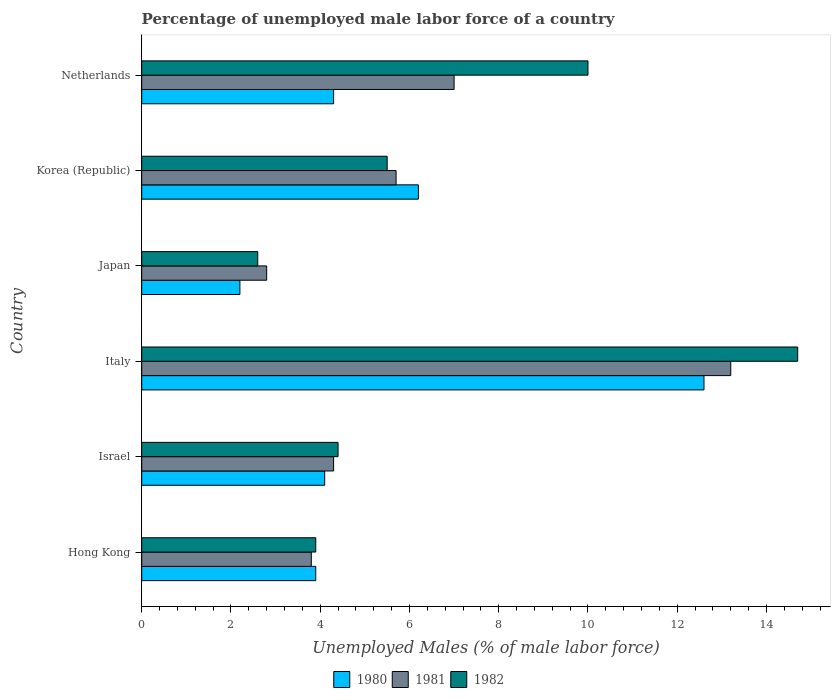How many different coloured bars are there?
Ensure brevity in your answer.  3. How many groups of bars are there?
Give a very brief answer. 6. Are the number of bars on each tick of the Y-axis equal?
Keep it short and to the point. Yes. How many bars are there on the 5th tick from the top?
Your response must be concise. 3. In how many cases, is the number of bars for a given country not equal to the number of legend labels?
Your response must be concise. 0. What is the percentage of unemployed male labor force in 1982 in Korea (Republic)?
Make the answer very short. 5.5. Across all countries, what is the maximum percentage of unemployed male labor force in 1982?
Your answer should be compact. 14.7. Across all countries, what is the minimum percentage of unemployed male labor force in 1982?
Provide a succinct answer. 2.6. What is the total percentage of unemployed male labor force in 1980 in the graph?
Ensure brevity in your answer.  33.3. What is the difference between the percentage of unemployed male labor force in 1982 in Hong Kong and that in Japan?
Ensure brevity in your answer.  1.3. What is the difference between the percentage of unemployed male labor force in 1980 in Japan and the percentage of unemployed male labor force in 1981 in Hong Kong?
Your answer should be very brief. -1.6. What is the average percentage of unemployed male labor force in 1982 per country?
Provide a succinct answer. 6.85. What is the difference between the percentage of unemployed male labor force in 1980 and percentage of unemployed male labor force in 1981 in Hong Kong?
Offer a terse response. 0.1. In how many countries, is the percentage of unemployed male labor force in 1980 greater than 5.6 %?
Your answer should be compact. 2. What is the ratio of the percentage of unemployed male labor force in 1981 in Hong Kong to that in Italy?
Provide a succinct answer. 0.29. Is the difference between the percentage of unemployed male labor force in 1980 in Italy and Netherlands greater than the difference between the percentage of unemployed male labor force in 1981 in Italy and Netherlands?
Your answer should be compact. Yes. What is the difference between the highest and the second highest percentage of unemployed male labor force in 1981?
Offer a terse response. 6.2. What is the difference between the highest and the lowest percentage of unemployed male labor force in 1980?
Keep it short and to the point. 10.4. What does the 1st bar from the top in Korea (Republic) represents?
Provide a short and direct response. 1982. What does the 3rd bar from the bottom in Israel represents?
Offer a terse response. 1982. Are all the bars in the graph horizontal?
Provide a short and direct response. Yes. How many countries are there in the graph?
Provide a succinct answer. 6. What is the difference between two consecutive major ticks on the X-axis?
Keep it short and to the point. 2. Does the graph contain any zero values?
Make the answer very short. No. Does the graph contain grids?
Offer a terse response. No. What is the title of the graph?
Give a very brief answer. Percentage of unemployed male labor force of a country. What is the label or title of the X-axis?
Offer a terse response. Unemployed Males (% of male labor force). What is the label or title of the Y-axis?
Your response must be concise. Country. What is the Unemployed Males (% of male labor force) in 1980 in Hong Kong?
Your response must be concise. 3.9. What is the Unemployed Males (% of male labor force) of 1981 in Hong Kong?
Offer a very short reply. 3.8. What is the Unemployed Males (% of male labor force) in 1982 in Hong Kong?
Provide a succinct answer. 3.9. What is the Unemployed Males (% of male labor force) of 1980 in Israel?
Offer a very short reply. 4.1. What is the Unemployed Males (% of male labor force) of 1981 in Israel?
Your answer should be compact. 4.3. What is the Unemployed Males (% of male labor force) in 1982 in Israel?
Keep it short and to the point. 4.4. What is the Unemployed Males (% of male labor force) in 1980 in Italy?
Provide a succinct answer. 12.6. What is the Unemployed Males (% of male labor force) of 1981 in Italy?
Offer a very short reply. 13.2. What is the Unemployed Males (% of male labor force) of 1982 in Italy?
Make the answer very short. 14.7. What is the Unemployed Males (% of male labor force) of 1980 in Japan?
Your answer should be very brief. 2.2. What is the Unemployed Males (% of male labor force) in 1981 in Japan?
Provide a short and direct response. 2.8. What is the Unemployed Males (% of male labor force) of 1982 in Japan?
Your answer should be very brief. 2.6. What is the Unemployed Males (% of male labor force) of 1980 in Korea (Republic)?
Your answer should be very brief. 6.2. What is the Unemployed Males (% of male labor force) in 1981 in Korea (Republic)?
Give a very brief answer. 5.7. What is the Unemployed Males (% of male labor force) of 1980 in Netherlands?
Offer a terse response. 4.3. What is the Unemployed Males (% of male labor force) of 1982 in Netherlands?
Offer a terse response. 10. Across all countries, what is the maximum Unemployed Males (% of male labor force) of 1980?
Ensure brevity in your answer.  12.6. Across all countries, what is the maximum Unemployed Males (% of male labor force) in 1981?
Your response must be concise. 13.2. Across all countries, what is the maximum Unemployed Males (% of male labor force) in 1982?
Provide a succinct answer. 14.7. Across all countries, what is the minimum Unemployed Males (% of male labor force) in 1980?
Provide a short and direct response. 2.2. Across all countries, what is the minimum Unemployed Males (% of male labor force) of 1981?
Offer a terse response. 2.8. Across all countries, what is the minimum Unemployed Males (% of male labor force) of 1982?
Ensure brevity in your answer.  2.6. What is the total Unemployed Males (% of male labor force) of 1980 in the graph?
Make the answer very short. 33.3. What is the total Unemployed Males (% of male labor force) in 1981 in the graph?
Make the answer very short. 36.8. What is the total Unemployed Males (% of male labor force) of 1982 in the graph?
Your answer should be compact. 41.1. What is the difference between the Unemployed Males (% of male labor force) in 1980 in Hong Kong and that in Israel?
Ensure brevity in your answer.  -0.2. What is the difference between the Unemployed Males (% of male labor force) in 1981 in Hong Kong and that in Italy?
Make the answer very short. -9.4. What is the difference between the Unemployed Males (% of male labor force) in 1980 in Hong Kong and that in Japan?
Offer a very short reply. 1.7. What is the difference between the Unemployed Males (% of male labor force) in 1981 in Hong Kong and that in Japan?
Provide a short and direct response. 1. What is the difference between the Unemployed Males (% of male labor force) in 1982 in Hong Kong and that in Japan?
Ensure brevity in your answer.  1.3. What is the difference between the Unemployed Males (% of male labor force) of 1980 in Hong Kong and that in Korea (Republic)?
Your answer should be very brief. -2.3. What is the difference between the Unemployed Males (% of male labor force) in 1981 in Hong Kong and that in Korea (Republic)?
Offer a very short reply. -1.9. What is the difference between the Unemployed Males (% of male labor force) in 1982 in Hong Kong and that in Korea (Republic)?
Keep it short and to the point. -1.6. What is the difference between the Unemployed Males (% of male labor force) of 1980 in Hong Kong and that in Netherlands?
Make the answer very short. -0.4. What is the difference between the Unemployed Males (% of male labor force) in 1982 in Hong Kong and that in Netherlands?
Keep it short and to the point. -6.1. What is the difference between the Unemployed Males (% of male labor force) of 1980 in Israel and that in Italy?
Your answer should be very brief. -8.5. What is the difference between the Unemployed Males (% of male labor force) of 1981 in Israel and that in Italy?
Provide a short and direct response. -8.9. What is the difference between the Unemployed Males (% of male labor force) of 1982 in Israel and that in Italy?
Your response must be concise. -10.3. What is the difference between the Unemployed Males (% of male labor force) in 1981 in Israel and that in Japan?
Give a very brief answer. 1.5. What is the difference between the Unemployed Males (% of male labor force) in 1981 in Israel and that in Korea (Republic)?
Provide a succinct answer. -1.4. What is the difference between the Unemployed Males (% of male labor force) in 1980 in Israel and that in Netherlands?
Make the answer very short. -0.2. What is the difference between the Unemployed Males (% of male labor force) in 1981 in Italy and that in Japan?
Give a very brief answer. 10.4. What is the difference between the Unemployed Males (% of male labor force) of 1980 in Italy and that in Korea (Republic)?
Provide a short and direct response. 6.4. What is the difference between the Unemployed Males (% of male labor force) in 1981 in Italy and that in Netherlands?
Offer a very short reply. 6.2. What is the difference between the Unemployed Males (% of male labor force) in 1980 in Japan and that in Korea (Republic)?
Provide a succinct answer. -4. What is the difference between the Unemployed Males (% of male labor force) of 1982 in Japan and that in Korea (Republic)?
Make the answer very short. -2.9. What is the difference between the Unemployed Males (% of male labor force) in 1982 in Japan and that in Netherlands?
Make the answer very short. -7.4. What is the difference between the Unemployed Males (% of male labor force) of 1981 in Korea (Republic) and that in Netherlands?
Offer a very short reply. -1.3. What is the difference between the Unemployed Males (% of male labor force) in 1980 in Hong Kong and the Unemployed Males (% of male labor force) in 1981 in Israel?
Your answer should be compact. -0.4. What is the difference between the Unemployed Males (% of male labor force) of 1980 in Hong Kong and the Unemployed Males (% of male labor force) of 1981 in Italy?
Your answer should be compact. -9.3. What is the difference between the Unemployed Males (% of male labor force) in 1980 in Hong Kong and the Unemployed Males (% of male labor force) in 1982 in Italy?
Your answer should be very brief. -10.8. What is the difference between the Unemployed Males (% of male labor force) of 1980 in Hong Kong and the Unemployed Males (% of male labor force) of 1981 in Japan?
Provide a succinct answer. 1.1. What is the difference between the Unemployed Males (% of male labor force) in 1980 in Hong Kong and the Unemployed Males (% of male labor force) in 1982 in Japan?
Your response must be concise. 1.3. What is the difference between the Unemployed Males (% of male labor force) in 1981 in Hong Kong and the Unemployed Males (% of male labor force) in 1982 in Japan?
Offer a very short reply. 1.2. What is the difference between the Unemployed Males (% of male labor force) of 1980 in Hong Kong and the Unemployed Males (% of male labor force) of 1981 in Korea (Republic)?
Your answer should be compact. -1.8. What is the difference between the Unemployed Males (% of male labor force) of 1981 in Hong Kong and the Unemployed Males (% of male labor force) of 1982 in Korea (Republic)?
Offer a very short reply. -1.7. What is the difference between the Unemployed Males (% of male labor force) of 1980 in Hong Kong and the Unemployed Males (% of male labor force) of 1981 in Netherlands?
Keep it short and to the point. -3.1. What is the difference between the Unemployed Males (% of male labor force) of 1980 in Israel and the Unemployed Males (% of male labor force) of 1981 in Italy?
Your response must be concise. -9.1. What is the difference between the Unemployed Males (% of male labor force) in 1980 in Israel and the Unemployed Males (% of male labor force) in 1982 in Italy?
Keep it short and to the point. -10.6. What is the difference between the Unemployed Males (% of male labor force) in 1980 in Israel and the Unemployed Males (% of male labor force) in 1982 in Japan?
Provide a succinct answer. 1.5. What is the difference between the Unemployed Males (% of male labor force) of 1981 in Israel and the Unemployed Males (% of male labor force) of 1982 in Japan?
Provide a succinct answer. 1.7. What is the difference between the Unemployed Males (% of male labor force) of 1980 in Israel and the Unemployed Males (% of male labor force) of 1981 in Korea (Republic)?
Your response must be concise. -1.6. What is the difference between the Unemployed Males (% of male labor force) of 1981 in Israel and the Unemployed Males (% of male labor force) of 1982 in Netherlands?
Make the answer very short. -5.7. What is the difference between the Unemployed Males (% of male labor force) of 1980 in Italy and the Unemployed Males (% of male labor force) of 1982 in Japan?
Your answer should be compact. 10. What is the difference between the Unemployed Males (% of male labor force) of 1980 in Italy and the Unemployed Males (% of male labor force) of 1981 in Korea (Republic)?
Your answer should be compact. 6.9. What is the difference between the Unemployed Males (% of male labor force) of 1981 in Italy and the Unemployed Males (% of male labor force) of 1982 in Korea (Republic)?
Keep it short and to the point. 7.7. What is the difference between the Unemployed Males (% of male labor force) in 1980 in Italy and the Unemployed Males (% of male labor force) in 1981 in Netherlands?
Provide a succinct answer. 5.6. What is the difference between the Unemployed Males (% of male labor force) in 1981 in Italy and the Unemployed Males (% of male labor force) in 1982 in Netherlands?
Keep it short and to the point. 3.2. What is the difference between the Unemployed Males (% of male labor force) in 1980 in Japan and the Unemployed Males (% of male labor force) in 1982 in Korea (Republic)?
Ensure brevity in your answer.  -3.3. What is the difference between the Unemployed Males (% of male labor force) in 1980 in Korea (Republic) and the Unemployed Males (% of male labor force) in 1981 in Netherlands?
Provide a short and direct response. -0.8. What is the difference between the Unemployed Males (% of male labor force) of 1981 in Korea (Republic) and the Unemployed Males (% of male labor force) of 1982 in Netherlands?
Provide a succinct answer. -4.3. What is the average Unemployed Males (% of male labor force) in 1980 per country?
Make the answer very short. 5.55. What is the average Unemployed Males (% of male labor force) of 1981 per country?
Give a very brief answer. 6.13. What is the average Unemployed Males (% of male labor force) of 1982 per country?
Your answer should be compact. 6.85. What is the difference between the Unemployed Males (% of male labor force) in 1980 and Unemployed Males (% of male labor force) in 1981 in Hong Kong?
Keep it short and to the point. 0.1. What is the difference between the Unemployed Males (% of male labor force) of 1980 and Unemployed Males (% of male labor force) of 1982 in Hong Kong?
Offer a very short reply. 0. What is the difference between the Unemployed Males (% of male labor force) in 1981 and Unemployed Males (% of male labor force) in 1982 in Hong Kong?
Make the answer very short. -0.1. What is the difference between the Unemployed Males (% of male labor force) of 1980 and Unemployed Males (% of male labor force) of 1982 in Israel?
Your response must be concise. -0.3. What is the difference between the Unemployed Males (% of male labor force) in 1980 and Unemployed Males (% of male labor force) in 1982 in Italy?
Provide a short and direct response. -2.1. What is the difference between the Unemployed Males (% of male labor force) of 1981 and Unemployed Males (% of male labor force) of 1982 in Italy?
Keep it short and to the point. -1.5. What is the difference between the Unemployed Males (% of male labor force) of 1981 and Unemployed Males (% of male labor force) of 1982 in Japan?
Provide a succinct answer. 0.2. What is the difference between the Unemployed Males (% of male labor force) in 1980 and Unemployed Males (% of male labor force) in 1981 in Korea (Republic)?
Provide a succinct answer. 0.5. What is the difference between the Unemployed Males (% of male labor force) of 1980 and Unemployed Males (% of male labor force) of 1982 in Korea (Republic)?
Your answer should be compact. 0.7. What is the difference between the Unemployed Males (% of male labor force) of 1981 and Unemployed Males (% of male labor force) of 1982 in Korea (Republic)?
Provide a short and direct response. 0.2. What is the difference between the Unemployed Males (% of male labor force) of 1980 and Unemployed Males (% of male labor force) of 1981 in Netherlands?
Your answer should be very brief. -2.7. What is the difference between the Unemployed Males (% of male labor force) in 1981 and Unemployed Males (% of male labor force) in 1982 in Netherlands?
Provide a succinct answer. -3. What is the ratio of the Unemployed Males (% of male labor force) of 1980 in Hong Kong to that in Israel?
Make the answer very short. 0.95. What is the ratio of the Unemployed Males (% of male labor force) in 1981 in Hong Kong to that in Israel?
Your response must be concise. 0.88. What is the ratio of the Unemployed Males (% of male labor force) of 1982 in Hong Kong to that in Israel?
Make the answer very short. 0.89. What is the ratio of the Unemployed Males (% of male labor force) in 1980 in Hong Kong to that in Italy?
Your answer should be compact. 0.31. What is the ratio of the Unemployed Males (% of male labor force) in 1981 in Hong Kong to that in Italy?
Your answer should be compact. 0.29. What is the ratio of the Unemployed Males (% of male labor force) in 1982 in Hong Kong to that in Italy?
Your answer should be compact. 0.27. What is the ratio of the Unemployed Males (% of male labor force) of 1980 in Hong Kong to that in Japan?
Keep it short and to the point. 1.77. What is the ratio of the Unemployed Males (% of male labor force) in 1981 in Hong Kong to that in Japan?
Give a very brief answer. 1.36. What is the ratio of the Unemployed Males (% of male labor force) in 1980 in Hong Kong to that in Korea (Republic)?
Offer a terse response. 0.63. What is the ratio of the Unemployed Males (% of male labor force) of 1982 in Hong Kong to that in Korea (Republic)?
Offer a terse response. 0.71. What is the ratio of the Unemployed Males (% of male labor force) in 1980 in Hong Kong to that in Netherlands?
Provide a succinct answer. 0.91. What is the ratio of the Unemployed Males (% of male labor force) of 1981 in Hong Kong to that in Netherlands?
Make the answer very short. 0.54. What is the ratio of the Unemployed Males (% of male labor force) in 1982 in Hong Kong to that in Netherlands?
Provide a succinct answer. 0.39. What is the ratio of the Unemployed Males (% of male labor force) of 1980 in Israel to that in Italy?
Your response must be concise. 0.33. What is the ratio of the Unemployed Males (% of male labor force) in 1981 in Israel to that in Italy?
Your response must be concise. 0.33. What is the ratio of the Unemployed Males (% of male labor force) in 1982 in Israel to that in Italy?
Make the answer very short. 0.3. What is the ratio of the Unemployed Males (% of male labor force) of 1980 in Israel to that in Japan?
Ensure brevity in your answer.  1.86. What is the ratio of the Unemployed Males (% of male labor force) of 1981 in Israel to that in Japan?
Offer a very short reply. 1.54. What is the ratio of the Unemployed Males (% of male labor force) in 1982 in Israel to that in Japan?
Provide a succinct answer. 1.69. What is the ratio of the Unemployed Males (% of male labor force) of 1980 in Israel to that in Korea (Republic)?
Keep it short and to the point. 0.66. What is the ratio of the Unemployed Males (% of male labor force) in 1981 in Israel to that in Korea (Republic)?
Your answer should be very brief. 0.75. What is the ratio of the Unemployed Males (% of male labor force) of 1982 in Israel to that in Korea (Republic)?
Your answer should be very brief. 0.8. What is the ratio of the Unemployed Males (% of male labor force) of 1980 in Israel to that in Netherlands?
Provide a succinct answer. 0.95. What is the ratio of the Unemployed Males (% of male labor force) of 1981 in Israel to that in Netherlands?
Provide a short and direct response. 0.61. What is the ratio of the Unemployed Males (% of male labor force) of 1982 in Israel to that in Netherlands?
Your answer should be compact. 0.44. What is the ratio of the Unemployed Males (% of male labor force) in 1980 in Italy to that in Japan?
Keep it short and to the point. 5.73. What is the ratio of the Unemployed Males (% of male labor force) of 1981 in Italy to that in Japan?
Ensure brevity in your answer.  4.71. What is the ratio of the Unemployed Males (% of male labor force) of 1982 in Italy to that in Japan?
Keep it short and to the point. 5.65. What is the ratio of the Unemployed Males (% of male labor force) in 1980 in Italy to that in Korea (Republic)?
Offer a very short reply. 2.03. What is the ratio of the Unemployed Males (% of male labor force) in 1981 in Italy to that in Korea (Republic)?
Ensure brevity in your answer.  2.32. What is the ratio of the Unemployed Males (% of male labor force) in 1982 in Italy to that in Korea (Republic)?
Provide a short and direct response. 2.67. What is the ratio of the Unemployed Males (% of male labor force) of 1980 in Italy to that in Netherlands?
Provide a short and direct response. 2.93. What is the ratio of the Unemployed Males (% of male labor force) of 1981 in Italy to that in Netherlands?
Offer a very short reply. 1.89. What is the ratio of the Unemployed Males (% of male labor force) of 1982 in Italy to that in Netherlands?
Ensure brevity in your answer.  1.47. What is the ratio of the Unemployed Males (% of male labor force) of 1980 in Japan to that in Korea (Republic)?
Offer a terse response. 0.35. What is the ratio of the Unemployed Males (% of male labor force) of 1981 in Japan to that in Korea (Republic)?
Your answer should be very brief. 0.49. What is the ratio of the Unemployed Males (% of male labor force) of 1982 in Japan to that in Korea (Republic)?
Provide a short and direct response. 0.47. What is the ratio of the Unemployed Males (% of male labor force) of 1980 in Japan to that in Netherlands?
Your answer should be compact. 0.51. What is the ratio of the Unemployed Males (% of male labor force) in 1981 in Japan to that in Netherlands?
Offer a very short reply. 0.4. What is the ratio of the Unemployed Males (% of male labor force) of 1982 in Japan to that in Netherlands?
Offer a very short reply. 0.26. What is the ratio of the Unemployed Males (% of male labor force) in 1980 in Korea (Republic) to that in Netherlands?
Offer a terse response. 1.44. What is the ratio of the Unemployed Males (% of male labor force) in 1981 in Korea (Republic) to that in Netherlands?
Ensure brevity in your answer.  0.81. What is the ratio of the Unemployed Males (% of male labor force) of 1982 in Korea (Republic) to that in Netherlands?
Give a very brief answer. 0.55. What is the difference between the highest and the second highest Unemployed Males (% of male labor force) of 1982?
Keep it short and to the point. 4.7. What is the difference between the highest and the lowest Unemployed Males (% of male labor force) of 1980?
Your answer should be very brief. 10.4. What is the difference between the highest and the lowest Unemployed Males (% of male labor force) of 1981?
Provide a succinct answer. 10.4. What is the difference between the highest and the lowest Unemployed Males (% of male labor force) of 1982?
Offer a terse response. 12.1. 